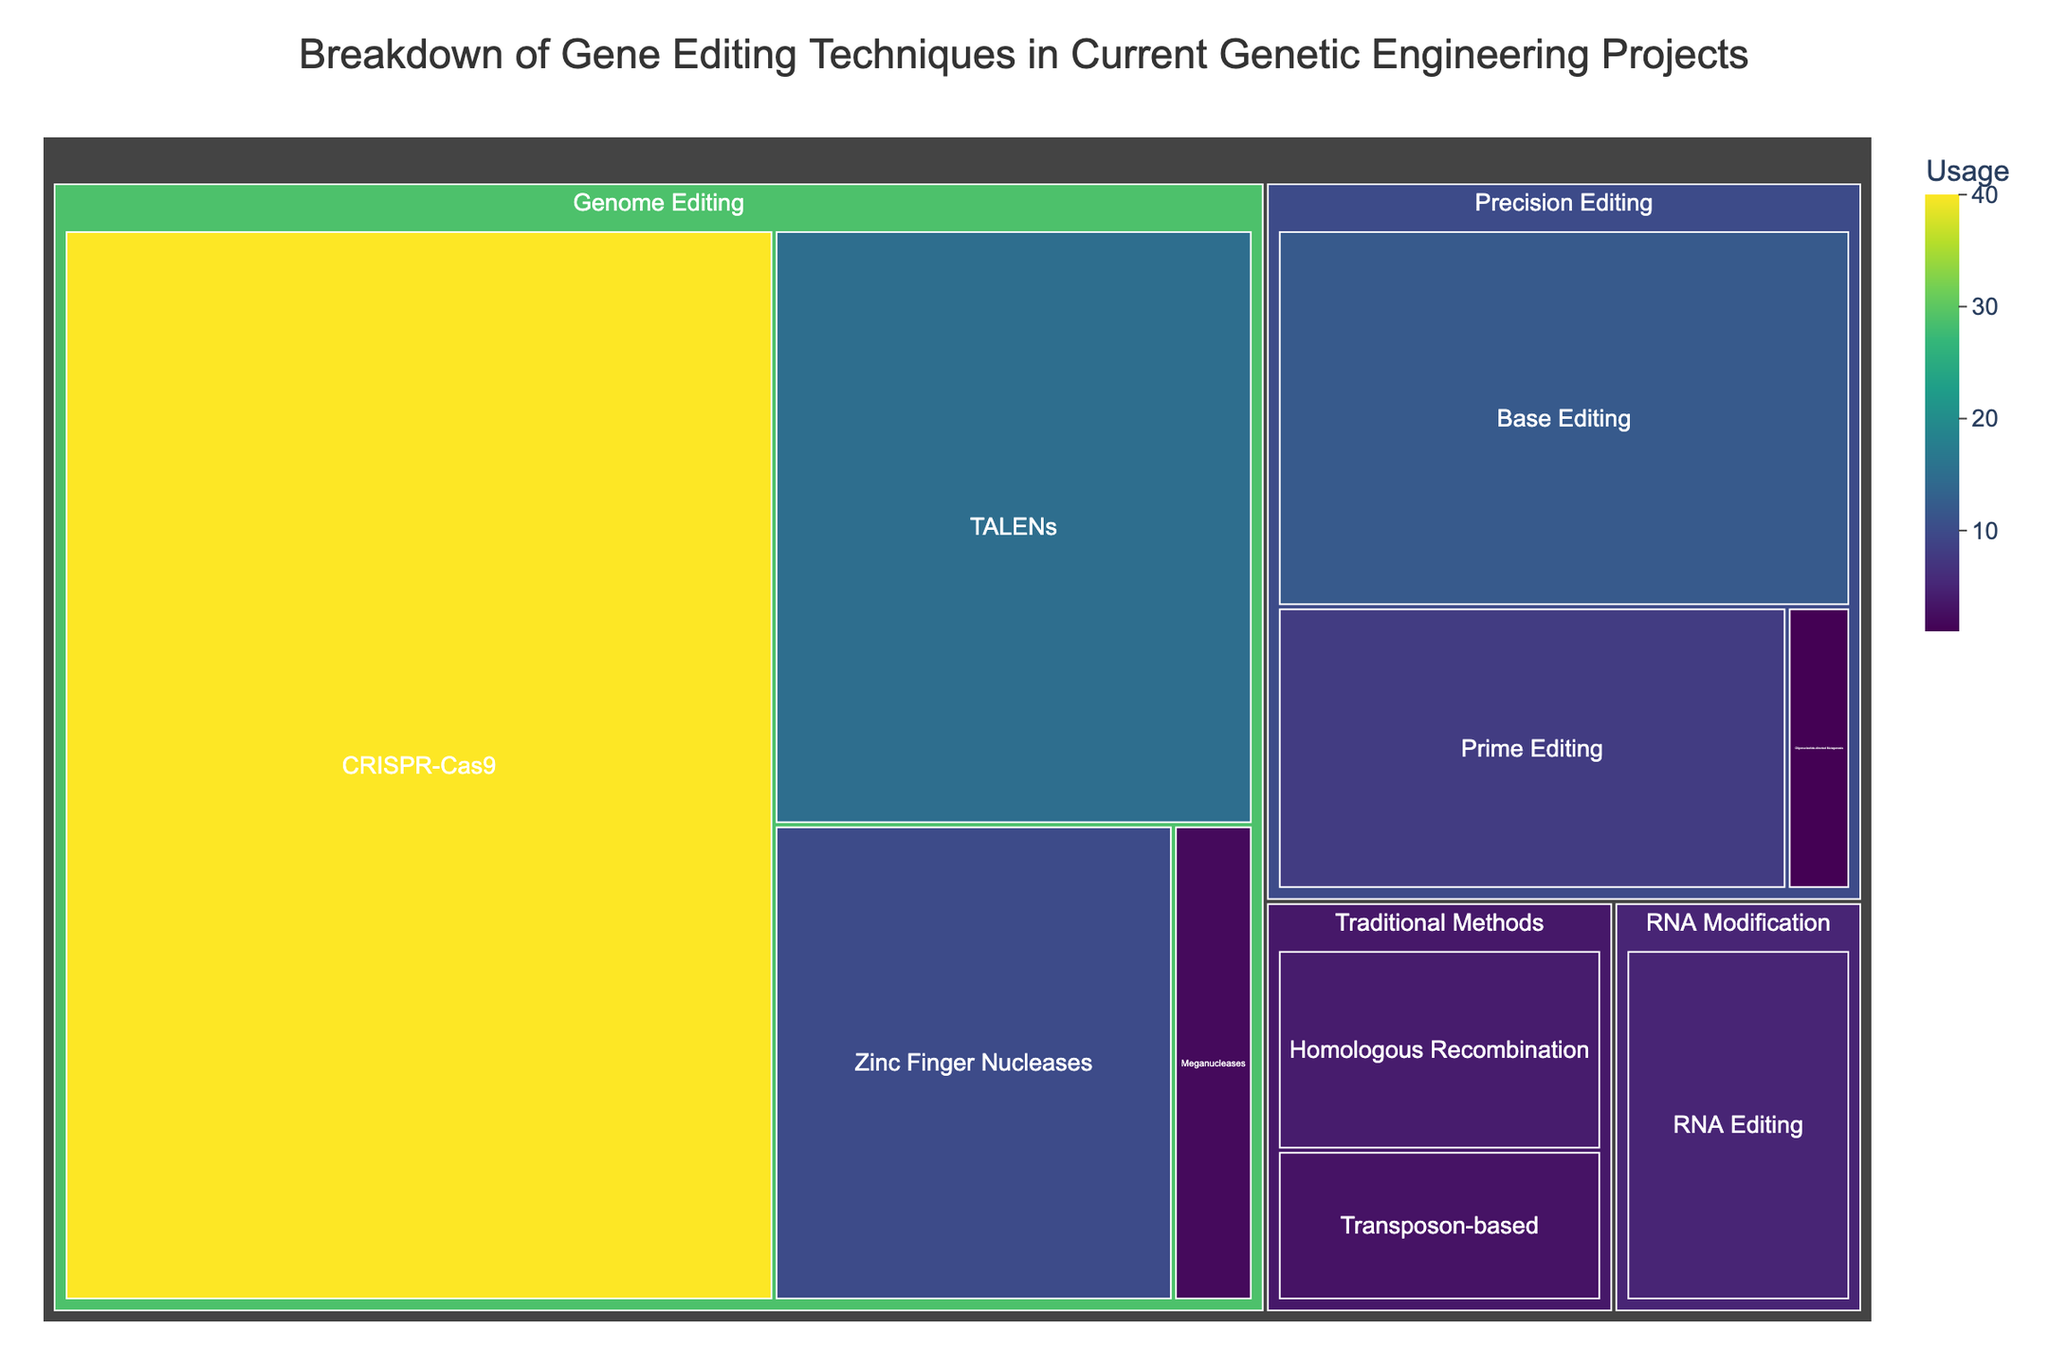What's the title of the treemap? The title of a chart is typically displayed at the top of the figure. By looking at the top area of the treemap, you can find the title which is "Breakdown of Gene Editing Techniques in Current Genetic Engineering Projects".
Answer: Breakdown of Gene Editing Techniques in Current Genetic Engineering Projects Which technique has the highest usage? To determine which technique has the highest usage, you need to identify the largest segment or the block with the highest numerical value. In this case, the largest segment is labeled "CRISPR-Cas9" with a usage value of 40.
Answer: CRISPR-Cas9 How many categories are there in the treemap? Categories can usually be identified by larger sections that encapsulate multiple techniques. By counting these larger sections, you can see there are four categories: Genome Editing, Precision Editing, RNA Modification, and Traditional Methods.
Answer: 4 What's the total usage of Precision Editing techniques? To find the total usage of Precision Editing techniques, you sum the usage values of each technique under this category: Base Editing (12), Prime Editing (8), and Oligonucleotide-directed Mutagenesis (1). So, 12 + 8 + 1 = 21.
Answer: 21 Which has a higher usage: TALENs or Base Editing? Compare the usage values directly from the treemap. TALENs has a usage value of 15, while Base Editing has a usage value of 12. Hence, TALENs has a higher usage.
Answer: TALENs What is the least used technique and its category? To find the least used technique, look for the smallest segment or the one with the smallest number. The smallest segment is "Oligonucleotide-directed Mutagenesis" with a usage value of 1, falling under the category of Precision Editing.
Answer: Oligonucleotide-directed Mutagenesis in Precision Editing What's the difference in usage between Homologous Recombination and Transposon-based techniques? Find the usage values of Homologous Recombination (4) and Transposon-based (3). Subtract the smaller number from the larger number to get the difference: 4 - 3 = 1.
Answer: 1 What's the total usage of techniques in the Genome Editing category? Sum the usage values of all techniques under Genome Editing: CRISPR-Cas9 (40), TALENs (15), Zinc Finger Nucleases (10), Meganucleases (2). So, 40 + 15 + 10 + 2 = 67.
Answer: 67 Which category has the smallest combined usage? To determine the category with the smallest combined usage, sum up the values for each category and compare them. RNA Modification has 5, Traditional Methods have 4 + 3 = 7, Precision Editing has 21, and Genome Editing has 67. Therefore, the RNA Modification category has the smallest usage.
Answer: RNA Modification 